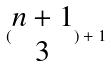<formula> <loc_0><loc_0><loc_500><loc_500>( \begin{matrix} n + 1 \\ 3 \end{matrix} ) + 1</formula> 